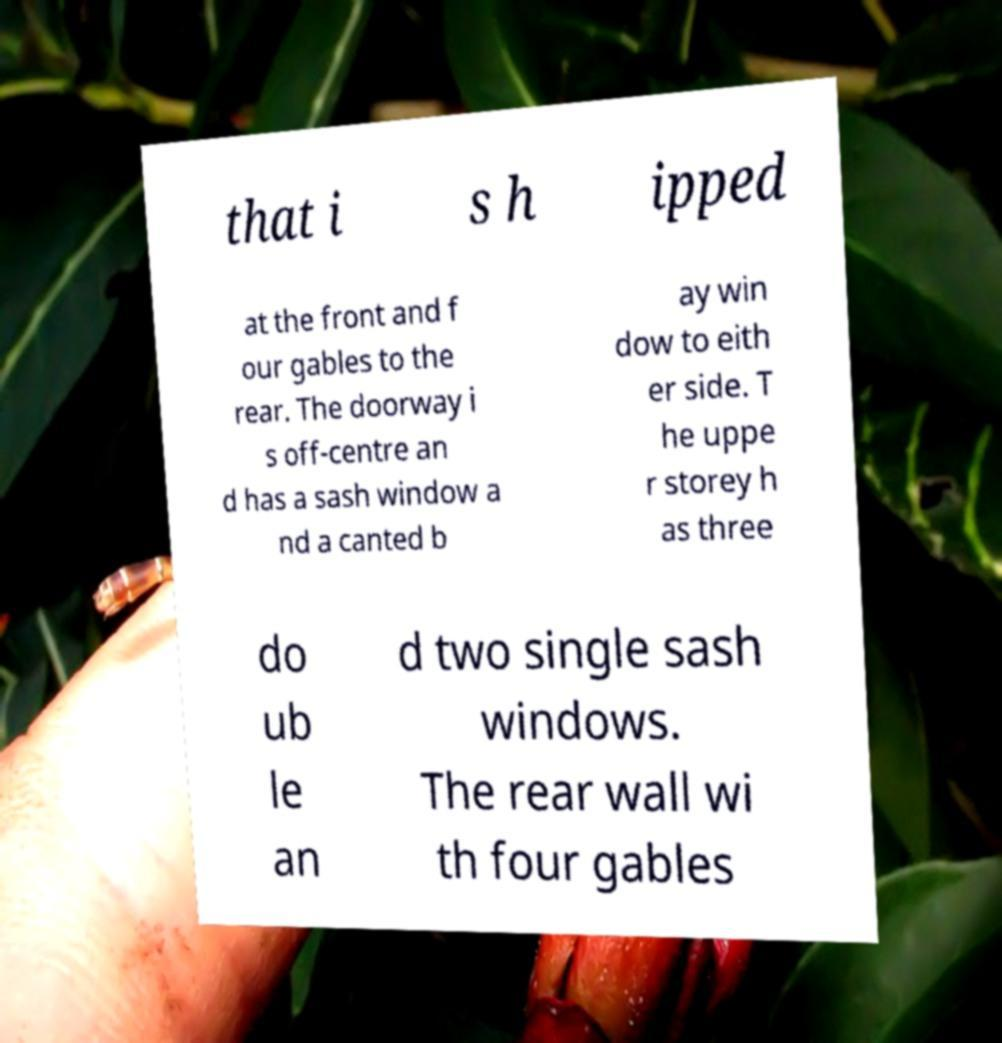I need the written content from this picture converted into text. Can you do that? that i s h ipped at the front and f our gables to the rear. The doorway i s off-centre an d has a sash window a nd a canted b ay win dow to eith er side. T he uppe r storey h as three do ub le an d two single sash windows. The rear wall wi th four gables 